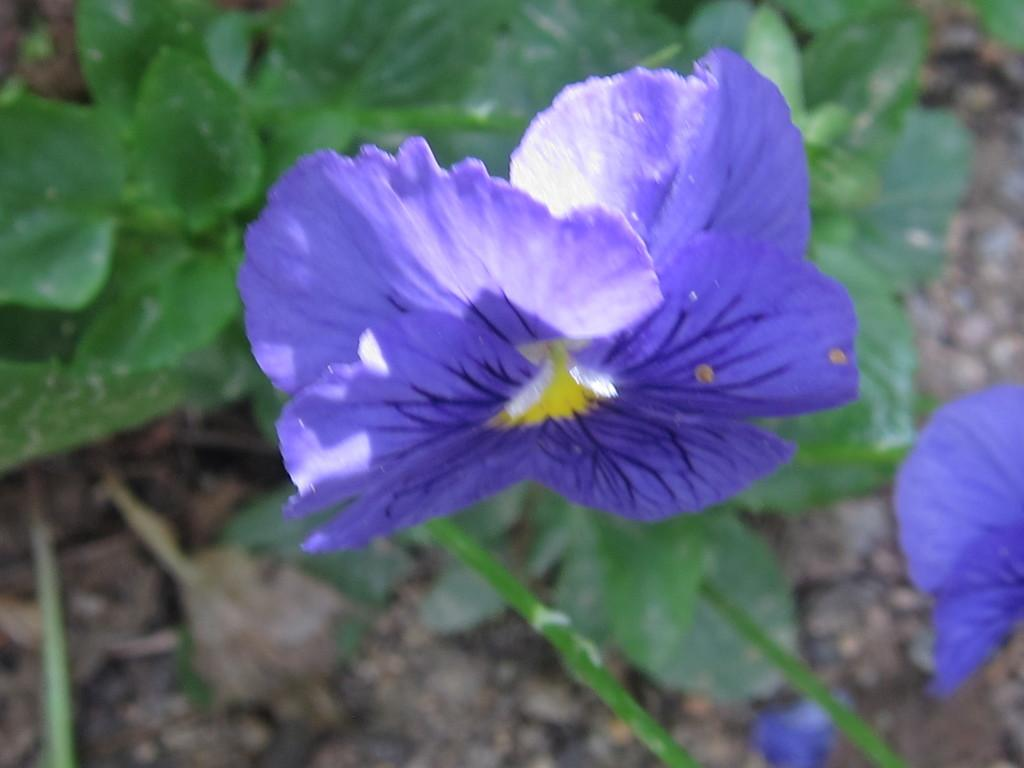What type of plant is visible in the image? There is a flower on a plant in the image. Can you describe the flower in more detail? Unfortunately, the provided facts do not give any additional information about the flower's appearance or characteristics. What relation does the flower have with the destruction of the plant in the image? There is no indication of destruction in the image, and the flower is not shown to have any relation to the plant's well-being. 